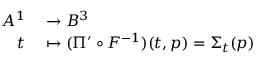<formula> <loc_0><loc_0><loc_500><loc_500>\begin{array} { r l } { A ^ { 1 } } & \to B ^ { 3 } } \\ { t } & \mapsto ( \Pi ^ { \prime } \circ F ^ { - 1 } ) ( t , p ) = \Sigma _ { t } ( p ) } \end{array}</formula> 